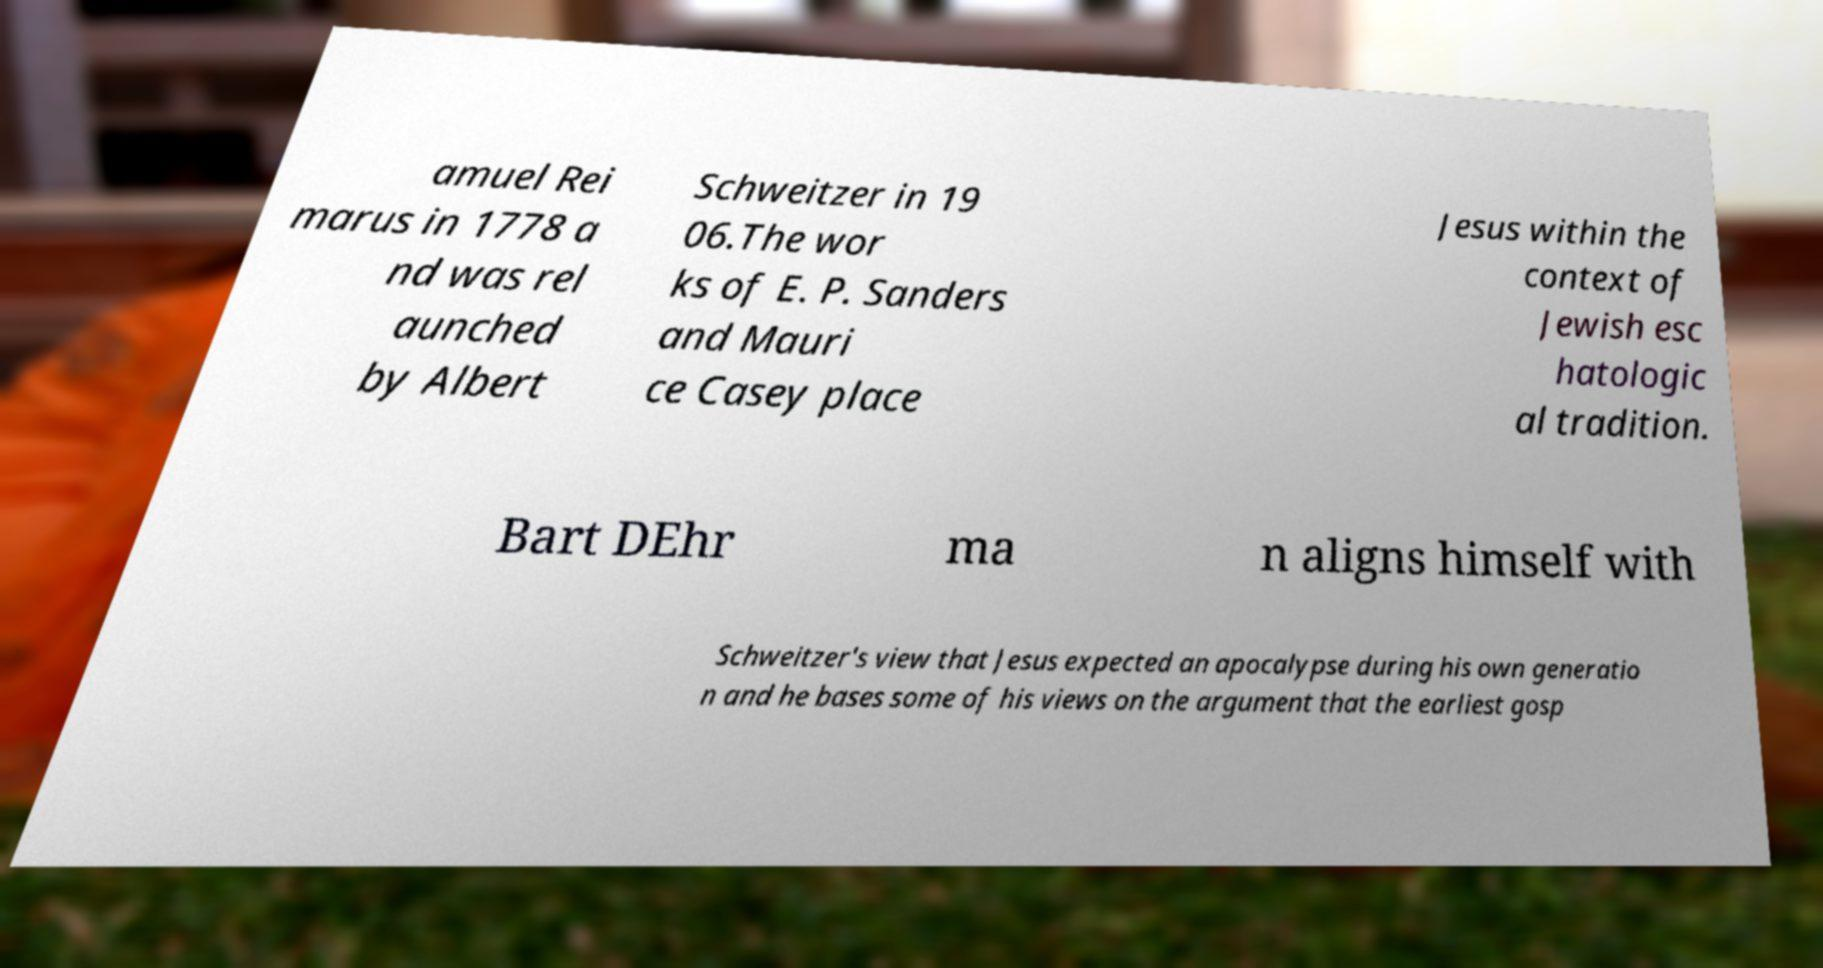Could you assist in decoding the text presented in this image and type it out clearly? amuel Rei marus in 1778 a nd was rel aunched by Albert Schweitzer in 19 06.The wor ks of E. P. Sanders and Mauri ce Casey place Jesus within the context of Jewish esc hatologic al tradition. Bart DEhr ma n aligns himself with Schweitzer's view that Jesus expected an apocalypse during his own generatio n and he bases some of his views on the argument that the earliest gosp 